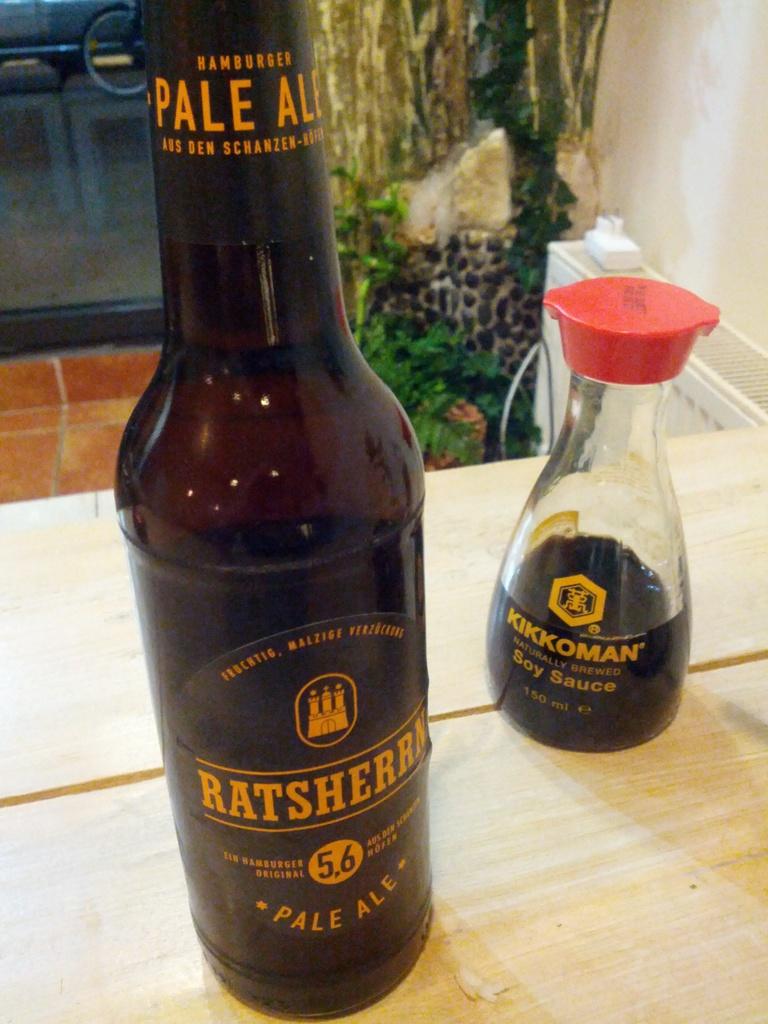What is the brand of soy sauce?
Your answer should be very brief. Kikkoman. How many ml are in the soy sauce?
Keep it short and to the point. 150. 